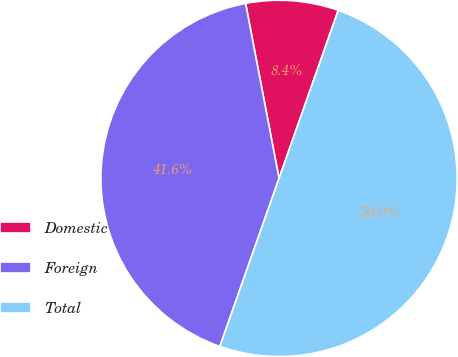Convert chart. <chart><loc_0><loc_0><loc_500><loc_500><pie_chart><fcel>Domestic<fcel>Foreign<fcel>Total<nl><fcel>8.4%<fcel>41.6%<fcel>50.0%<nl></chart> 